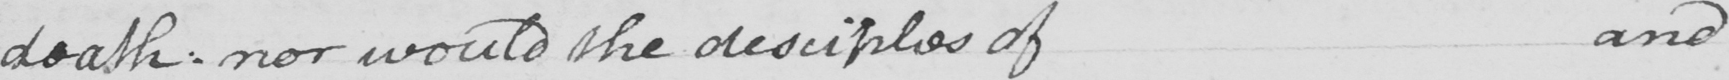Please transcribe the handwritten text in this image. death . nor would the desciples of and 